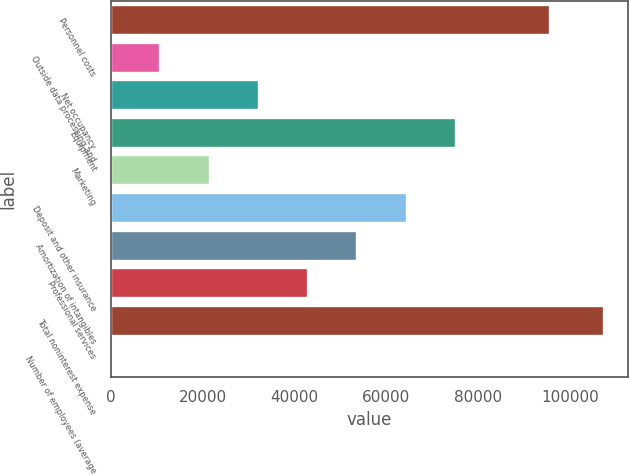Convert chart. <chart><loc_0><loc_0><loc_500><loc_500><bar_chart><fcel>Personnel costs<fcel>Outside data processing and<fcel>Net occupancy<fcel>Equipment<fcel>Marketing<fcel>Deposit and other insurance<fcel>Amortization of intangibles<fcel>Professional services<fcel>Total noninterest expense<fcel>Number of employees (average<nl><fcel>95659<fcel>10824<fcel>32280<fcel>75192<fcel>21552<fcel>64464<fcel>53736<fcel>43008<fcel>107376<fcel>96<nl></chart> 